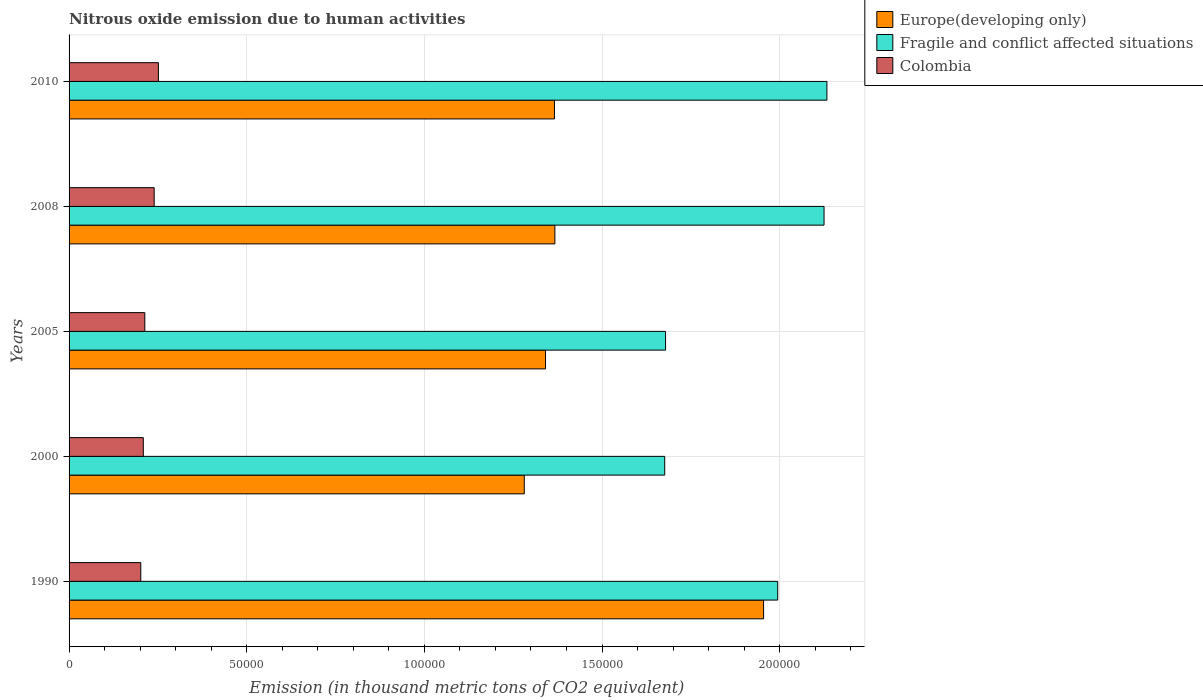How many groups of bars are there?
Keep it short and to the point. 5. How many bars are there on the 3rd tick from the top?
Your answer should be very brief. 3. What is the amount of nitrous oxide emitted in Europe(developing only) in 1990?
Offer a very short reply. 1.95e+05. Across all years, what is the maximum amount of nitrous oxide emitted in Europe(developing only)?
Provide a succinct answer. 1.95e+05. Across all years, what is the minimum amount of nitrous oxide emitted in Fragile and conflict affected situations?
Keep it short and to the point. 1.68e+05. In which year was the amount of nitrous oxide emitted in Europe(developing only) maximum?
Your answer should be compact. 1990. What is the total amount of nitrous oxide emitted in Europe(developing only) in the graph?
Your answer should be compact. 7.31e+05. What is the difference between the amount of nitrous oxide emitted in Fragile and conflict affected situations in 2000 and that in 2008?
Offer a terse response. -4.48e+04. What is the difference between the amount of nitrous oxide emitted in Colombia in 2005 and the amount of nitrous oxide emitted in Europe(developing only) in 2000?
Provide a succinct answer. -1.07e+05. What is the average amount of nitrous oxide emitted in Colombia per year?
Offer a very short reply. 2.23e+04. In the year 2005, what is the difference between the amount of nitrous oxide emitted in Europe(developing only) and amount of nitrous oxide emitted in Colombia?
Your answer should be very brief. 1.13e+05. What is the ratio of the amount of nitrous oxide emitted in Fragile and conflict affected situations in 1990 to that in 2008?
Offer a very short reply. 0.94. What is the difference between the highest and the second highest amount of nitrous oxide emitted in Fragile and conflict affected situations?
Ensure brevity in your answer.  807. What is the difference between the highest and the lowest amount of nitrous oxide emitted in Fragile and conflict affected situations?
Keep it short and to the point. 4.57e+04. In how many years, is the amount of nitrous oxide emitted in Colombia greater than the average amount of nitrous oxide emitted in Colombia taken over all years?
Keep it short and to the point. 2. What does the 2nd bar from the top in 2010 represents?
Give a very brief answer. Fragile and conflict affected situations. What does the 2nd bar from the bottom in 2005 represents?
Make the answer very short. Fragile and conflict affected situations. How many bars are there?
Your answer should be compact. 15. What is the difference between two consecutive major ticks on the X-axis?
Offer a very short reply. 5.00e+04. Where does the legend appear in the graph?
Make the answer very short. Top right. How many legend labels are there?
Your answer should be compact. 3. What is the title of the graph?
Your answer should be very brief. Nitrous oxide emission due to human activities. Does "Macedonia" appear as one of the legend labels in the graph?
Offer a very short reply. No. What is the label or title of the X-axis?
Provide a succinct answer. Emission (in thousand metric tons of CO2 equivalent). What is the Emission (in thousand metric tons of CO2 equivalent) in Europe(developing only) in 1990?
Keep it short and to the point. 1.95e+05. What is the Emission (in thousand metric tons of CO2 equivalent) of Fragile and conflict affected situations in 1990?
Provide a short and direct response. 1.99e+05. What is the Emission (in thousand metric tons of CO2 equivalent) of Colombia in 1990?
Offer a very short reply. 2.02e+04. What is the Emission (in thousand metric tons of CO2 equivalent) of Europe(developing only) in 2000?
Provide a succinct answer. 1.28e+05. What is the Emission (in thousand metric tons of CO2 equivalent) of Fragile and conflict affected situations in 2000?
Offer a terse response. 1.68e+05. What is the Emission (in thousand metric tons of CO2 equivalent) of Colombia in 2000?
Offer a terse response. 2.09e+04. What is the Emission (in thousand metric tons of CO2 equivalent) in Europe(developing only) in 2005?
Make the answer very short. 1.34e+05. What is the Emission (in thousand metric tons of CO2 equivalent) in Fragile and conflict affected situations in 2005?
Your response must be concise. 1.68e+05. What is the Emission (in thousand metric tons of CO2 equivalent) in Colombia in 2005?
Provide a short and direct response. 2.13e+04. What is the Emission (in thousand metric tons of CO2 equivalent) of Europe(developing only) in 2008?
Ensure brevity in your answer.  1.37e+05. What is the Emission (in thousand metric tons of CO2 equivalent) of Fragile and conflict affected situations in 2008?
Ensure brevity in your answer.  2.12e+05. What is the Emission (in thousand metric tons of CO2 equivalent) in Colombia in 2008?
Your response must be concise. 2.39e+04. What is the Emission (in thousand metric tons of CO2 equivalent) in Europe(developing only) in 2010?
Ensure brevity in your answer.  1.37e+05. What is the Emission (in thousand metric tons of CO2 equivalent) of Fragile and conflict affected situations in 2010?
Ensure brevity in your answer.  2.13e+05. What is the Emission (in thousand metric tons of CO2 equivalent) in Colombia in 2010?
Ensure brevity in your answer.  2.51e+04. Across all years, what is the maximum Emission (in thousand metric tons of CO2 equivalent) in Europe(developing only)?
Ensure brevity in your answer.  1.95e+05. Across all years, what is the maximum Emission (in thousand metric tons of CO2 equivalent) of Fragile and conflict affected situations?
Provide a short and direct response. 2.13e+05. Across all years, what is the maximum Emission (in thousand metric tons of CO2 equivalent) of Colombia?
Your response must be concise. 2.51e+04. Across all years, what is the minimum Emission (in thousand metric tons of CO2 equivalent) in Europe(developing only)?
Your response must be concise. 1.28e+05. Across all years, what is the minimum Emission (in thousand metric tons of CO2 equivalent) in Fragile and conflict affected situations?
Keep it short and to the point. 1.68e+05. Across all years, what is the minimum Emission (in thousand metric tons of CO2 equivalent) of Colombia?
Your answer should be very brief. 2.02e+04. What is the total Emission (in thousand metric tons of CO2 equivalent) of Europe(developing only) in the graph?
Offer a very short reply. 7.31e+05. What is the total Emission (in thousand metric tons of CO2 equivalent) in Fragile and conflict affected situations in the graph?
Offer a terse response. 9.61e+05. What is the total Emission (in thousand metric tons of CO2 equivalent) in Colombia in the graph?
Offer a terse response. 1.11e+05. What is the difference between the Emission (in thousand metric tons of CO2 equivalent) in Europe(developing only) in 1990 and that in 2000?
Your answer should be very brief. 6.74e+04. What is the difference between the Emission (in thousand metric tons of CO2 equivalent) in Fragile and conflict affected situations in 1990 and that in 2000?
Provide a succinct answer. 3.18e+04. What is the difference between the Emission (in thousand metric tons of CO2 equivalent) in Colombia in 1990 and that in 2000?
Give a very brief answer. -706.7. What is the difference between the Emission (in thousand metric tons of CO2 equivalent) of Europe(developing only) in 1990 and that in 2005?
Ensure brevity in your answer.  6.14e+04. What is the difference between the Emission (in thousand metric tons of CO2 equivalent) of Fragile and conflict affected situations in 1990 and that in 2005?
Keep it short and to the point. 3.16e+04. What is the difference between the Emission (in thousand metric tons of CO2 equivalent) in Colombia in 1990 and that in 2005?
Give a very brief answer. -1134.8. What is the difference between the Emission (in thousand metric tons of CO2 equivalent) of Europe(developing only) in 1990 and that in 2008?
Your response must be concise. 5.87e+04. What is the difference between the Emission (in thousand metric tons of CO2 equivalent) in Fragile and conflict affected situations in 1990 and that in 2008?
Offer a terse response. -1.30e+04. What is the difference between the Emission (in thousand metric tons of CO2 equivalent) of Colombia in 1990 and that in 2008?
Ensure brevity in your answer.  -3767.8. What is the difference between the Emission (in thousand metric tons of CO2 equivalent) in Europe(developing only) in 1990 and that in 2010?
Ensure brevity in your answer.  5.89e+04. What is the difference between the Emission (in thousand metric tons of CO2 equivalent) in Fragile and conflict affected situations in 1990 and that in 2010?
Your response must be concise. -1.38e+04. What is the difference between the Emission (in thousand metric tons of CO2 equivalent) of Colombia in 1990 and that in 2010?
Provide a succinct answer. -4960.2. What is the difference between the Emission (in thousand metric tons of CO2 equivalent) of Europe(developing only) in 2000 and that in 2005?
Ensure brevity in your answer.  -5992.3. What is the difference between the Emission (in thousand metric tons of CO2 equivalent) in Fragile and conflict affected situations in 2000 and that in 2005?
Your response must be concise. -238.1. What is the difference between the Emission (in thousand metric tons of CO2 equivalent) of Colombia in 2000 and that in 2005?
Your answer should be compact. -428.1. What is the difference between the Emission (in thousand metric tons of CO2 equivalent) in Europe(developing only) in 2000 and that in 2008?
Keep it short and to the point. -8618.7. What is the difference between the Emission (in thousand metric tons of CO2 equivalent) in Fragile and conflict affected situations in 2000 and that in 2008?
Your answer should be very brief. -4.48e+04. What is the difference between the Emission (in thousand metric tons of CO2 equivalent) in Colombia in 2000 and that in 2008?
Your answer should be very brief. -3061.1. What is the difference between the Emission (in thousand metric tons of CO2 equivalent) of Europe(developing only) in 2000 and that in 2010?
Your response must be concise. -8495.7. What is the difference between the Emission (in thousand metric tons of CO2 equivalent) in Fragile and conflict affected situations in 2000 and that in 2010?
Offer a terse response. -4.57e+04. What is the difference between the Emission (in thousand metric tons of CO2 equivalent) in Colombia in 2000 and that in 2010?
Give a very brief answer. -4253.5. What is the difference between the Emission (in thousand metric tons of CO2 equivalent) in Europe(developing only) in 2005 and that in 2008?
Give a very brief answer. -2626.4. What is the difference between the Emission (in thousand metric tons of CO2 equivalent) in Fragile and conflict affected situations in 2005 and that in 2008?
Offer a very short reply. -4.46e+04. What is the difference between the Emission (in thousand metric tons of CO2 equivalent) of Colombia in 2005 and that in 2008?
Ensure brevity in your answer.  -2633. What is the difference between the Emission (in thousand metric tons of CO2 equivalent) in Europe(developing only) in 2005 and that in 2010?
Your response must be concise. -2503.4. What is the difference between the Emission (in thousand metric tons of CO2 equivalent) of Fragile and conflict affected situations in 2005 and that in 2010?
Make the answer very short. -4.54e+04. What is the difference between the Emission (in thousand metric tons of CO2 equivalent) in Colombia in 2005 and that in 2010?
Your answer should be very brief. -3825.4. What is the difference between the Emission (in thousand metric tons of CO2 equivalent) in Europe(developing only) in 2008 and that in 2010?
Ensure brevity in your answer.  123. What is the difference between the Emission (in thousand metric tons of CO2 equivalent) of Fragile and conflict affected situations in 2008 and that in 2010?
Your response must be concise. -807. What is the difference between the Emission (in thousand metric tons of CO2 equivalent) in Colombia in 2008 and that in 2010?
Your answer should be very brief. -1192.4. What is the difference between the Emission (in thousand metric tons of CO2 equivalent) of Europe(developing only) in 1990 and the Emission (in thousand metric tons of CO2 equivalent) of Fragile and conflict affected situations in 2000?
Ensure brevity in your answer.  2.78e+04. What is the difference between the Emission (in thousand metric tons of CO2 equivalent) of Europe(developing only) in 1990 and the Emission (in thousand metric tons of CO2 equivalent) of Colombia in 2000?
Ensure brevity in your answer.  1.75e+05. What is the difference between the Emission (in thousand metric tons of CO2 equivalent) in Fragile and conflict affected situations in 1990 and the Emission (in thousand metric tons of CO2 equivalent) in Colombia in 2000?
Offer a very short reply. 1.79e+05. What is the difference between the Emission (in thousand metric tons of CO2 equivalent) in Europe(developing only) in 1990 and the Emission (in thousand metric tons of CO2 equivalent) in Fragile and conflict affected situations in 2005?
Offer a terse response. 2.76e+04. What is the difference between the Emission (in thousand metric tons of CO2 equivalent) of Europe(developing only) in 1990 and the Emission (in thousand metric tons of CO2 equivalent) of Colombia in 2005?
Offer a terse response. 1.74e+05. What is the difference between the Emission (in thousand metric tons of CO2 equivalent) in Fragile and conflict affected situations in 1990 and the Emission (in thousand metric tons of CO2 equivalent) in Colombia in 2005?
Ensure brevity in your answer.  1.78e+05. What is the difference between the Emission (in thousand metric tons of CO2 equivalent) of Europe(developing only) in 1990 and the Emission (in thousand metric tons of CO2 equivalent) of Fragile and conflict affected situations in 2008?
Provide a succinct answer. -1.70e+04. What is the difference between the Emission (in thousand metric tons of CO2 equivalent) in Europe(developing only) in 1990 and the Emission (in thousand metric tons of CO2 equivalent) in Colombia in 2008?
Your response must be concise. 1.72e+05. What is the difference between the Emission (in thousand metric tons of CO2 equivalent) of Fragile and conflict affected situations in 1990 and the Emission (in thousand metric tons of CO2 equivalent) of Colombia in 2008?
Offer a terse response. 1.75e+05. What is the difference between the Emission (in thousand metric tons of CO2 equivalent) of Europe(developing only) in 1990 and the Emission (in thousand metric tons of CO2 equivalent) of Fragile and conflict affected situations in 2010?
Give a very brief answer. -1.78e+04. What is the difference between the Emission (in thousand metric tons of CO2 equivalent) in Europe(developing only) in 1990 and the Emission (in thousand metric tons of CO2 equivalent) in Colombia in 2010?
Offer a very short reply. 1.70e+05. What is the difference between the Emission (in thousand metric tons of CO2 equivalent) of Fragile and conflict affected situations in 1990 and the Emission (in thousand metric tons of CO2 equivalent) of Colombia in 2010?
Make the answer very short. 1.74e+05. What is the difference between the Emission (in thousand metric tons of CO2 equivalent) in Europe(developing only) in 2000 and the Emission (in thousand metric tons of CO2 equivalent) in Fragile and conflict affected situations in 2005?
Your answer should be compact. -3.98e+04. What is the difference between the Emission (in thousand metric tons of CO2 equivalent) in Europe(developing only) in 2000 and the Emission (in thousand metric tons of CO2 equivalent) in Colombia in 2005?
Offer a very short reply. 1.07e+05. What is the difference between the Emission (in thousand metric tons of CO2 equivalent) of Fragile and conflict affected situations in 2000 and the Emission (in thousand metric tons of CO2 equivalent) of Colombia in 2005?
Make the answer very short. 1.46e+05. What is the difference between the Emission (in thousand metric tons of CO2 equivalent) of Europe(developing only) in 2000 and the Emission (in thousand metric tons of CO2 equivalent) of Fragile and conflict affected situations in 2008?
Give a very brief answer. -8.44e+04. What is the difference between the Emission (in thousand metric tons of CO2 equivalent) in Europe(developing only) in 2000 and the Emission (in thousand metric tons of CO2 equivalent) in Colombia in 2008?
Keep it short and to the point. 1.04e+05. What is the difference between the Emission (in thousand metric tons of CO2 equivalent) in Fragile and conflict affected situations in 2000 and the Emission (in thousand metric tons of CO2 equivalent) in Colombia in 2008?
Provide a short and direct response. 1.44e+05. What is the difference between the Emission (in thousand metric tons of CO2 equivalent) in Europe(developing only) in 2000 and the Emission (in thousand metric tons of CO2 equivalent) in Fragile and conflict affected situations in 2010?
Give a very brief answer. -8.52e+04. What is the difference between the Emission (in thousand metric tons of CO2 equivalent) in Europe(developing only) in 2000 and the Emission (in thousand metric tons of CO2 equivalent) in Colombia in 2010?
Give a very brief answer. 1.03e+05. What is the difference between the Emission (in thousand metric tons of CO2 equivalent) in Fragile and conflict affected situations in 2000 and the Emission (in thousand metric tons of CO2 equivalent) in Colombia in 2010?
Your answer should be compact. 1.42e+05. What is the difference between the Emission (in thousand metric tons of CO2 equivalent) of Europe(developing only) in 2005 and the Emission (in thousand metric tons of CO2 equivalent) of Fragile and conflict affected situations in 2008?
Provide a succinct answer. -7.84e+04. What is the difference between the Emission (in thousand metric tons of CO2 equivalent) of Europe(developing only) in 2005 and the Emission (in thousand metric tons of CO2 equivalent) of Colombia in 2008?
Offer a terse response. 1.10e+05. What is the difference between the Emission (in thousand metric tons of CO2 equivalent) in Fragile and conflict affected situations in 2005 and the Emission (in thousand metric tons of CO2 equivalent) in Colombia in 2008?
Your response must be concise. 1.44e+05. What is the difference between the Emission (in thousand metric tons of CO2 equivalent) in Europe(developing only) in 2005 and the Emission (in thousand metric tons of CO2 equivalent) in Fragile and conflict affected situations in 2010?
Make the answer very short. -7.92e+04. What is the difference between the Emission (in thousand metric tons of CO2 equivalent) of Europe(developing only) in 2005 and the Emission (in thousand metric tons of CO2 equivalent) of Colombia in 2010?
Offer a very short reply. 1.09e+05. What is the difference between the Emission (in thousand metric tons of CO2 equivalent) of Fragile and conflict affected situations in 2005 and the Emission (in thousand metric tons of CO2 equivalent) of Colombia in 2010?
Make the answer very short. 1.43e+05. What is the difference between the Emission (in thousand metric tons of CO2 equivalent) in Europe(developing only) in 2008 and the Emission (in thousand metric tons of CO2 equivalent) in Fragile and conflict affected situations in 2010?
Your answer should be compact. -7.66e+04. What is the difference between the Emission (in thousand metric tons of CO2 equivalent) of Europe(developing only) in 2008 and the Emission (in thousand metric tons of CO2 equivalent) of Colombia in 2010?
Your response must be concise. 1.12e+05. What is the difference between the Emission (in thousand metric tons of CO2 equivalent) in Fragile and conflict affected situations in 2008 and the Emission (in thousand metric tons of CO2 equivalent) in Colombia in 2010?
Your response must be concise. 1.87e+05. What is the average Emission (in thousand metric tons of CO2 equivalent) in Europe(developing only) per year?
Your answer should be very brief. 1.46e+05. What is the average Emission (in thousand metric tons of CO2 equivalent) of Fragile and conflict affected situations per year?
Provide a succinct answer. 1.92e+05. What is the average Emission (in thousand metric tons of CO2 equivalent) in Colombia per year?
Your response must be concise. 2.23e+04. In the year 1990, what is the difference between the Emission (in thousand metric tons of CO2 equivalent) of Europe(developing only) and Emission (in thousand metric tons of CO2 equivalent) of Fragile and conflict affected situations?
Ensure brevity in your answer.  -3969.9. In the year 1990, what is the difference between the Emission (in thousand metric tons of CO2 equivalent) of Europe(developing only) and Emission (in thousand metric tons of CO2 equivalent) of Colombia?
Give a very brief answer. 1.75e+05. In the year 1990, what is the difference between the Emission (in thousand metric tons of CO2 equivalent) of Fragile and conflict affected situations and Emission (in thousand metric tons of CO2 equivalent) of Colombia?
Your answer should be compact. 1.79e+05. In the year 2000, what is the difference between the Emission (in thousand metric tons of CO2 equivalent) in Europe(developing only) and Emission (in thousand metric tons of CO2 equivalent) in Fragile and conflict affected situations?
Give a very brief answer. -3.95e+04. In the year 2000, what is the difference between the Emission (in thousand metric tons of CO2 equivalent) of Europe(developing only) and Emission (in thousand metric tons of CO2 equivalent) of Colombia?
Your response must be concise. 1.07e+05. In the year 2000, what is the difference between the Emission (in thousand metric tons of CO2 equivalent) in Fragile and conflict affected situations and Emission (in thousand metric tons of CO2 equivalent) in Colombia?
Your response must be concise. 1.47e+05. In the year 2005, what is the difference between the Emission (in thousand metric tons of CO2 equivalent) of Europe(developing only) and Emission (in thousand metric tons of CO2 equivalent) of Fragile and conflict affected situations?
Provide a short and direct response. -3.38e+04. In the year 2005, what is the difference between the Emission (in thousand metric tons of CO2 equivalent) of Europe(developing only) and Emission (in thousand metric tons of CO2 equivalent) of Colombia?
Provide a succinct answer. 1.13e+05. In the year 2005, what is the difference between the Emission (in thousand metric tons of CO2 equivalent) in Fragile and conflict affected situations and Emission (in thousand metric tons of CO2 equivalent) in Colombia?
Offer a terse response. 1.47e+05. In the year 2008, what is the difference between the Emission (in thousand metric tons of CO2 equivalent) in Europe(developing only) and Emission (in thousand metric tons of CO2 equivalent) in Fragile and conflict affected situations?
Your answer should be compact. -7.58e+04. In the year 2008, what is the difference between the Emission (in thousand metric tons of CO2 equivalent) of Europe(developing only) and Emission (in thousand metric tons of CO2 equivalent) of Colombia?
Provide a succinct answer. 1.13e+05. In the year 2008, what is the difference between the Emission (in thousand metric tons of CO2 equivalent) in Fragile and conflict affected situations and Emission (in thousand metric tons of CO2 equivalent) in Colombia?
Offer a terse response. 1.89e+05. In the year 2010, what is the difference between the Emission (in thousand metric tons of CO2 equivalent) in Europe(developing only) and Emission (in thousand metric tons of CO2 equivalent) in Fragile and conflict affected situations?
Give a very brief answer. -7.67e+04. In the year 2010, what is the difference between the Emission (in thousand metric tons of CO2 equivalent) of Europe(developing only) and Emission (in thousand metric tons of CO2 equivalent) of Colombia?
Your response must be concise. 1.11e+05. In the year 2010, what is the difference between the Emission (in thousand metric tons of CO2 equivalent) of Fragile and conflict affected situations and Emission (in thousand metric tons of CO2 equivalent) of Colombia?
Your response must be concise. 1.88e+05. What is the ratio of the Emission (in thousand metric tons of CO2 equivalent) of Europe(developing only) in 1990 to that in 2000?
Make the answer very short. 1.53. What is the ratio of the Emission (in thousand metric tons of CO2 equivalent) in Fragile and conflict affected situations in 1990 to that in 2000?
Give a very brief answer. 1.19. What is the ratio of the Emission (in thousand metric tons of CO2 equivalent) in Colombia in 1990 to that in 2000?
Offer a terse response. 0.97. What is the ratio of the Emission (in thousand metric tons of CO2 equivalent) of Europe(developing only) in 1990 to that in 2005?
Offer a terse response. 1.46. What is the ratio of the Emission (in thousand metric tons of CO2 equivalent) of Fragile and conflict affected situations in 1990 to that in 2005?
Offer a terse response. 1.19. What is the ratio of the Emission (in thousand metric tons of CO2 equivalent) in Colombia in 1990 to that in 2005?
Provide a short and direct response. 0.95. What is the ratio of the Emission (in thousand metric tons of CO2 equivalent) in Europe(developing only) in 1990 to that in 2008?
Provide a short and direct response. 1.43. What is the ratio of the Emission (in thousand metric tons of CO2 equivalent) of Fragile and conflict affected situations in 1990 to that in 2008?
Offer a very short reply. 0.94. What is the ratio of the Emission (in thousand metric tons of CO2 equivalent) in Colombia in 1990 to that in 2008?
Provide a short and direct response. 0.84. What is the ratio of the Emission (in thousand metric tons of CO2 equivalent) in Europe(developing only) in 1990 to that in 2010?
Your response must be concise. 1.43. What is the ratio of the Emission (in thousand metric tons of CO2 equivalent) of Fragile and conflict affected situations in 1990 to that in 2010?
Give a very brief answer. 0.94. What is the ratio of the Emission (in thousand metric tons of CO2 equivalent) in Colombia in 1990 to that in 2010?
Offer a terse response. 0.8. What is the ratio of the Emission (in thousand metric tons of CO2 equivalent) of Europe(developing only) in 2000 to that in 2005?
Your answer should be very brief. 0.96. What is the ratio of the Emission (in thousand metric tons of CO2 equivalent) of Fragile and conflict affected situations in 2000 to that in 2005?
Your answer should be very brief. 1. What is the ratio of the Emission (in thousand metric tons of CO2 equivalent) of Colombia in 2000 to that in 2005?
Offer a very short reply. 0.98. What is the ratio of the Emission (in thousand metric tons of CO2 equivalent) of Europe(developing only) in 2000 to that in 2008?
Your answer should be compact. 0.94. What is the ratio of the Emission (in thousand metric tons of CO2 equivalent) of Fragile and conflict affected situations in 2000 to that in 2008?
Offer a terse response. 0.79. What is the ratio of the Emission (in thousand metric tons of CO2 equivalent) of Colombia in 2000 to that in 2008?
Your answer should be very brief. 0.87. What is the ratio of the Emission (in thousand metric tons of CO2 equivalent) in Europe(developing only) in 2000 to that in 2010?
Offer a terse response. 0.94. What is the ratio of the Emission (in thousand metric tons of CO2 equivalent) in Fragile and conflict affected situations in 2000 to that in 2010?
Provide a short and direct response. 0.79. What is the ratio of the Emission (in thousand metric tons of CO2 equivalent) of Colombia in 2000 to that in 2010?
Your answer should be very brief. 0.83. What is the ratio of the Emission (in thousand metric tons of CO2 equivalent) in Europe(developing only) in 2005 to that in 2008?
Keep it short and to the point. 0.98. What is the ratio of the Emission (in thousand metric tons of CO2 equivalent) in Fragile and conflict affected situations in 2005 to that in 2008?
Offer a terse response. 0.79. What is the ratio of the Emission (in thousand metric tons of CO2 equivalent) of Colombia in 2005 to that in 2008?
Provide a short and direct response. 0.89. What is the ratio of the Emission (in thousand metric tons of CO2 equivalent) of Europe(developing only) in 2005 to that in 2010?
Make the answer very short. 0.98. What is the ratio of the Emission (in thousand metric tons of CO2 equivalent) in Fragile and conflict affected situations in 2005 to that in 2010?
Your answer should be very brief. 0.79. What is the ratio of the Emission (in thousand metric tons of CO2 equivalent) in Colombia in 2005 to that in 2010?
Your response must be concise. 0.85. What is the ratio of the Emission (in thousand metric tons of CO2 equivalent) in Fragile and conflict affected situations in 2008 to that in 2010?
Your answer should be compact. 1. What is the ratio of the Emission (in thousand metric tons of CO2 equivalent) of Colombia in 2008 to that in 2010?
Provide a succinct answer. 0.95. What is the difference between the highest and the second highest Emission (in thousand metric tons of CO2 equivalent) in Europe(developing only)?
Provide a succinct answer. 5.87e+04. What is the difference between the highest and the second highest Emission (in thousand metric tons of CO2 equivalent) in Fragile and conflict affected situations?
Give a very brief answer. 807. What is the difference between the highest and the second highest Emission (in thousand metric tons of CO2 equivalent) of Colombia?
Make the answer very short. 1192.4. What is the difference between the highest and the lowest Emission (in thousand metric tons of CO2 equivalent) of Europe(developing only)?
Your answer should be very brief. 6.74e+04. What is the difference between the highest and the lowest Emission (in thousand metric tons of CO2 equivalent) of Fragile and conflict affected situations?
Your answer should be very brief. 4.57e+04. What is the difference between the highest and the lowest Emission (in thousand metric tons of CO2 equivalent) in Colombia?
Offer a terse response. 4960.2. 